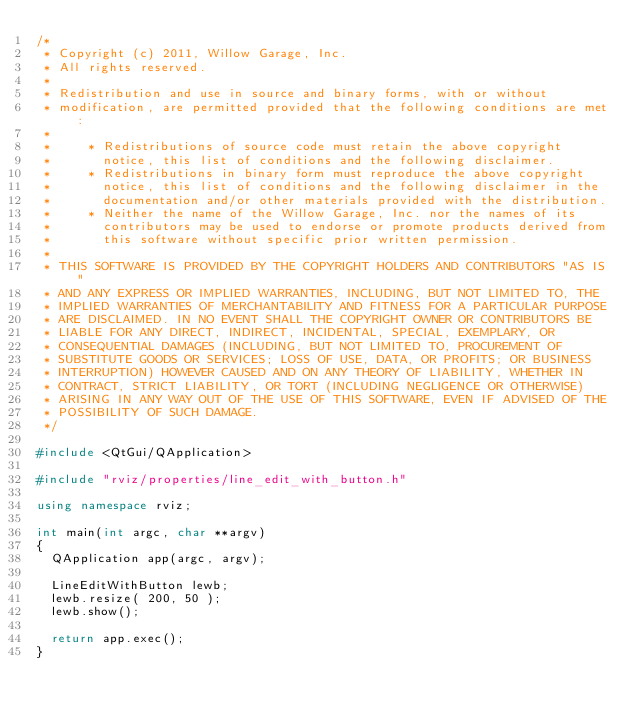<code> <loc_0><loc_0><loc_500><loc_500><_C++_>/*
 * Copyright (c) 2011, Willow Garage, Inc.
 * All rights reserved.
 *
 * Redistribution and use in source and binary forms, with or without
 * modification, are permitted provided that the following conditions are met:
 *
 *     * Redistributions of source code must retain the above copyright
 *       notice, this list of conditions and the following disclaimer.
 *     * Redistributions in binary form must reproduce the above copyright
 *       notice, this list of conditions and the following disclaimer in the
 *       documentation and/or other materials provided with the distribution.
 *     * Neither the name of the Willow Garage, Inc. nor the names of its
 *       contributors may be used to endorse or promote products derived from
 *       this software without specific prior written permission.
 *
 * THIS SOFTWARE IS PROVIDED BY THE COPYRIGHT HOLDERS AND CONTRIBUTORS "AS IS"
 * AND ANY EXPRESS OR IMPLIED WARRANTIES, INCLUDING, BUT NOT LIMITED TO, THE
 * IMPLIED WARRANTIES OF MERCHANTABILITY AND FITNESS FOR A PARTICULAR PURPOSE
 * ARE DISCLAIMED. IN NO EVENT SHALL THE COPYRIGHT OWNER OR CONTRIBUTORS BE
 * LIABLE FOR ANY DIRECT, INDIRECT, INCIDENTAL, SPECIAL, EXEMPLARY, OR
 * CONSEQUENTIAL DAMAGES (INCLUDING, BUT NOT LIMITED TO, PROCUREMENT OF
 * SUBSTITUTE GOODS OR SERVICES; LOSS OF USE, DATA, OR PROFITS; OR BUSINESS
 * INTERRUPTION) HOWEVER CAUSED AND ON ANY THEORY OF LIABILITY, WHETHER IN
 * CONTRACT, STRICT LIABILITY, OR TORT (INCLUDING NEGLIGENCE OR OTHERWISE)
 * ARISING IN ANY WAY OUT OF THE USE OF THIS SOFTWARE, EVEN IF ADVISED OF THE
 * POSSIBILITY OF SUCH DAMAGE.
 */

#include <QtGui/QApplication>

#include "rviz/properties/line_edit_with_button.h"

using namespace rviz;

int main(int argc, char **argv)
{
  QApplication app(argc, argv);

  LineEditWithButton lewb;
  lewb.resize( 200, 50 );
  lewb.show();

  return app.exec();
}
</code> 